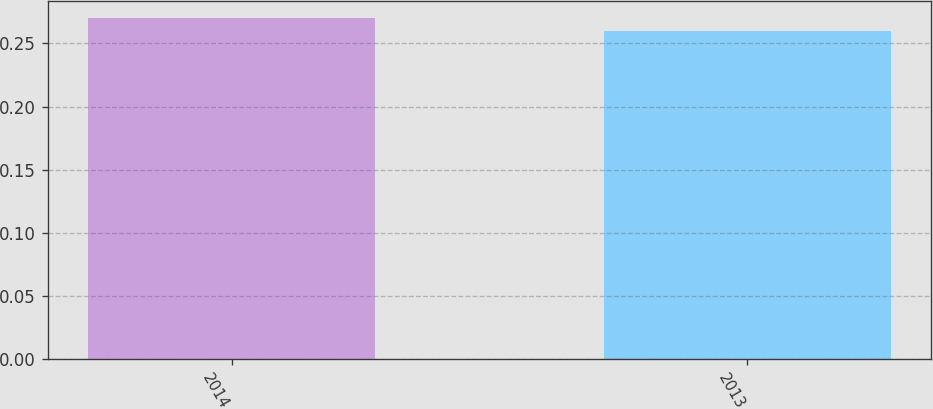<chart> <loc_0><loc_0><loc_500><loc_500><bar_chart><fcel>2014<fcel>2013<nl><fcel>0.27<fcel>0.26<nl></chart> 